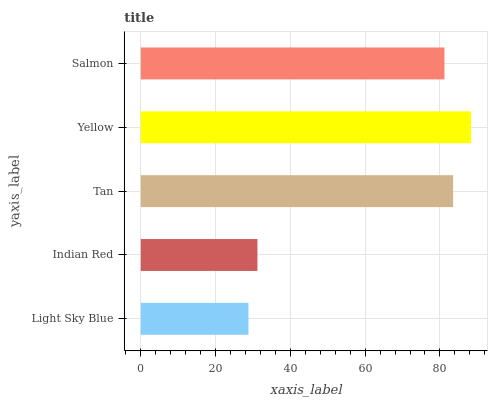Is Light Sky Blue the minimum?
Answer yes or no. Yes. Is Yellow the maximum?
Answer yes or no. Yes. Is Indian Red the minimum?
Answer yes or no. No. Is Indian Red the maximum?
Answer yes or no. No. Is Indian Red greater than Light Sky Blue?
Answer yes or no. Yes. Is Light Sky Blue less than Indian Red?
Answer yes or no. Yes. Is Light Sky Blue greater than Indian Red?
Answer yes or no. No. Is Indian Red less than Light Sky Blue?
Answer yes or no. No. Is Salmon the high median?
Answer yes or no. Yes. Is Salmon the low median?
Answer yes or no. Yes. Is Indian Red the high median?
Answer yes or no. No. Is Yellow the low median?
Answer yes or no. No. 